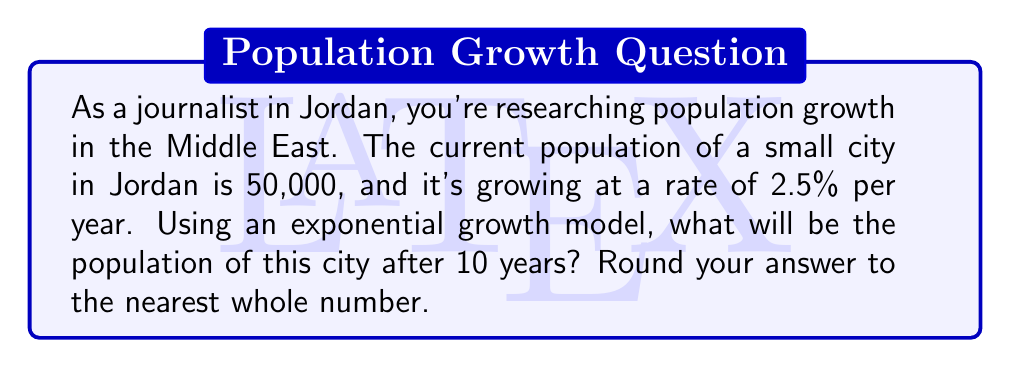Provide a solution to this math problem. To solve this problem, we'll use the exponential growth formula:

$$A = P(1 + r)^t$$

Where:
$A$ = Final amount (population after 10 years)
$P$ = Initial principal (current population)
$r$ = Growth rate (as a decimal)
$t$ = Time period (in years)

Given:
$P = 50,000$
$r = 2.5\% = 0.025$
$t = 10$ years

Step 1: Plug the values into the formula
$$A = 50,000(1 + 0.025)^{10}$$

Step 2: Calculate $(1 + 0.025)^{10}$
$$(1.025)^{10} \approx 1.2800975$$

Step 3: Multiply by the initial population
$$A = 50,000 \times 1.2800975 \approx 64,004.875$$

Step 4: Round to the nearest whole number
$$A \approx 64,005$$

Therefore, the population of the city after 10 years will be approximately 64,005 people.
Answer: 64,005 people 